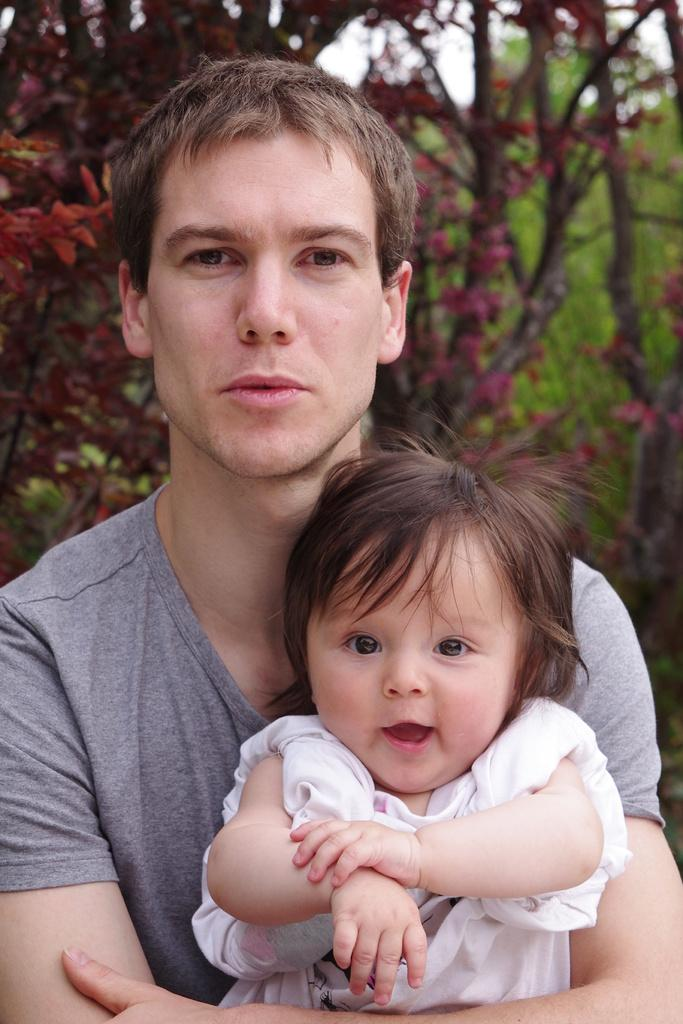How many people are in the image? There are two persons in the image. What can be seen in the background of the image? There are trees in the background of the image. What is visible at the top of the image? The sky is visible at the top of the image. What type of brush is being used by the scarecrow in the image? There is no scarecrow or brush present in the image. How much powder is needed to cover the entire area in the image? There is no powder or indication of a need for powder in the image. 